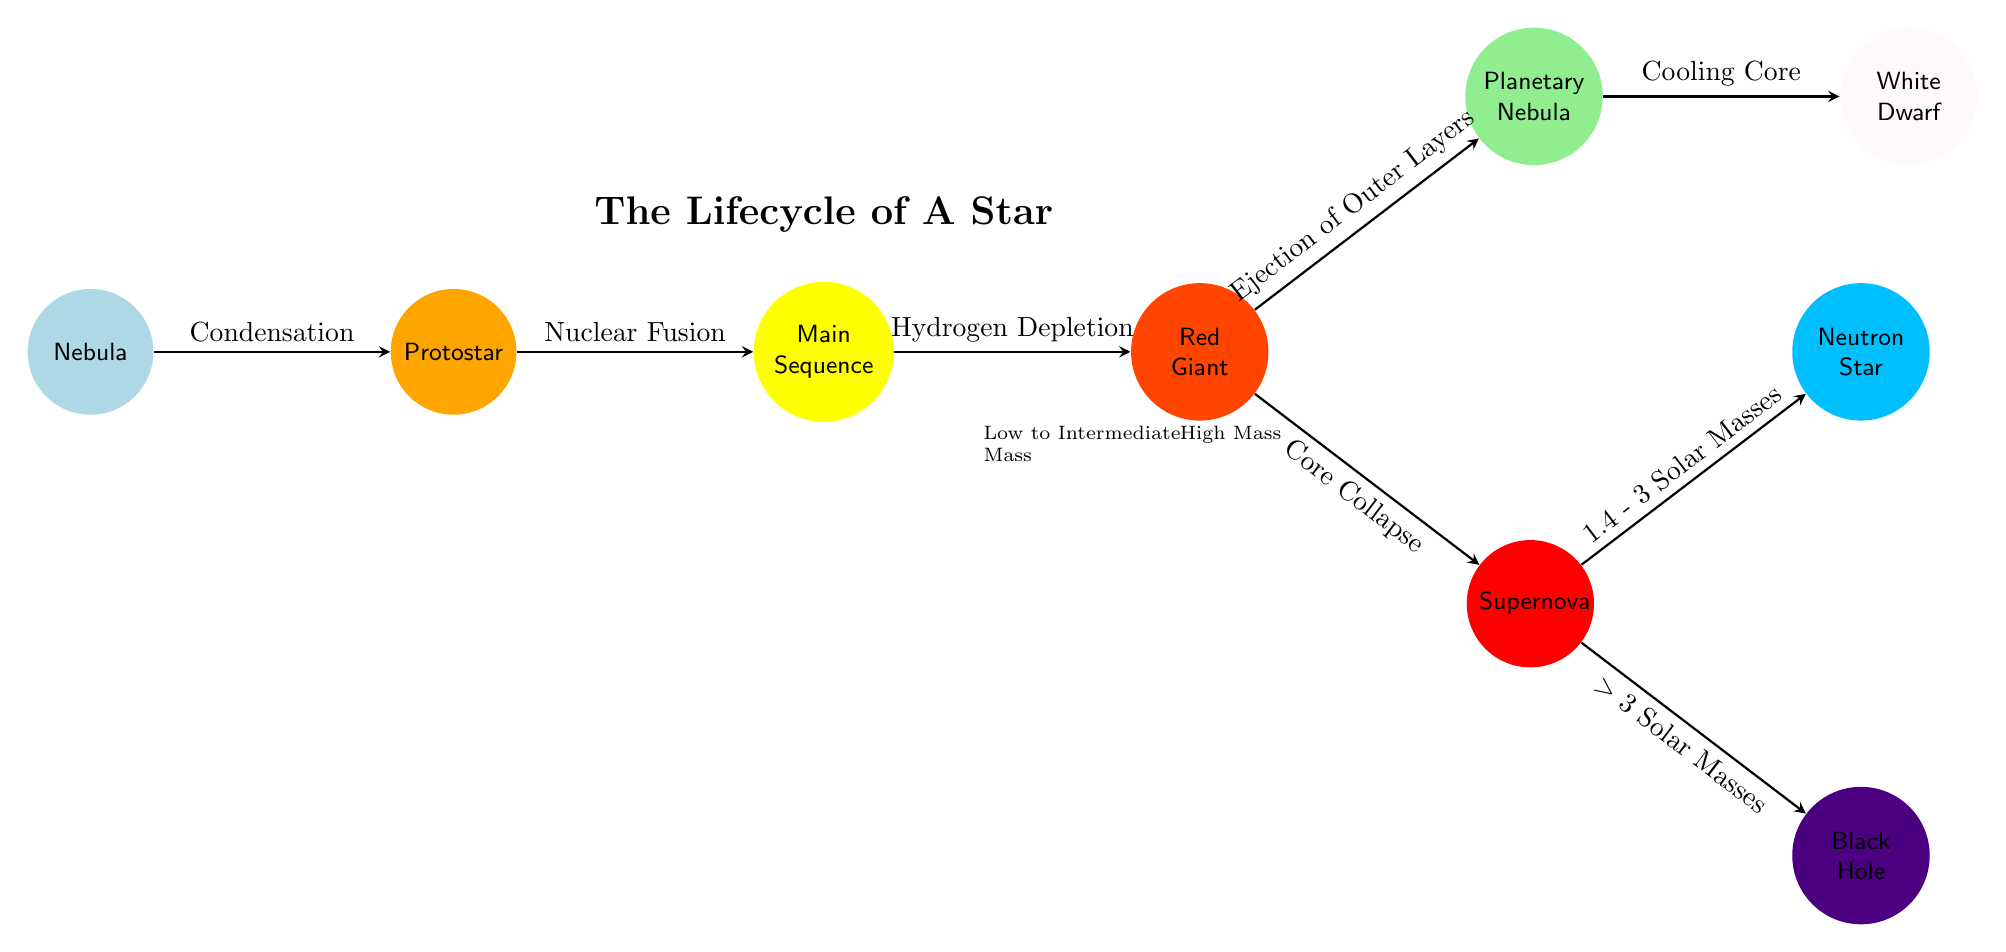What is the first stage in the lifecycle of a star? Looking at the leftmost node in the diagram, it is labeled "Nebula," which represents the initial stage in the lifecycle of a star.
Answer: Nebula How many stages are depicted in the diagram? Counting the nodes (each representing a stage), there are a total of 9 different stages.
Answer: 9 What happens after the Main Sequence stage? From the Main Sequence node, the diagram shows an edge leading to the Red Giant stage, indicating that this is the next stage after the Main Sequence.
Answer: Red Giant What processes lead to the formation of a Protostar? The arrow connecting the Nebula to the Protostar indicates the process of "Condensation," which is essential for forming a Protostar.
Answer: Condensation What are the two outcomes after a Supernova? The diagram branches out from the Supernova node to two nodes: Neutron Star and Black Hole, which represent two potential outcomes based on mass.
Answer: Neutron Star and Black Hole Which stage is characterized by Ejection of Outer Layers? The edge connecting the Red Giant to the Planetary Nebula is labeled "Ejection of Outer Layers," indicating that this stage is characterized by this process.
Answer: Planetary Nebula What mass range is associated with the formation of a Neutron Star after a Supernova? The label on the edge leading to the Neutron Star specifies "1.4 - 3 Solar Masses," which defines the mass range for this outcome.
Answer: 1.4 - 3 Solar Masses Which stage follows the cooling core of a White Dwarf? The sequence of stages after the White Dwarf is not explicitly shown, but it logically ends after cooling, implying that the lifecycle does not progress further.
Answer: No further stage What distinguishes Low to Intermediate Mass from High Mass in the diagram? The labels placed below the Red Giant node, one indicating "Low to Intermediate Mass" and the other "High Mass," define the star mass categories influencing the paths taken after the Red Giant.
Answer: Low to Intermediate Mass and High Mass 